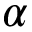Convert formula to latex. <formula><loc_0><loc_0><loc_500><loc_500>\alpha</formula> 